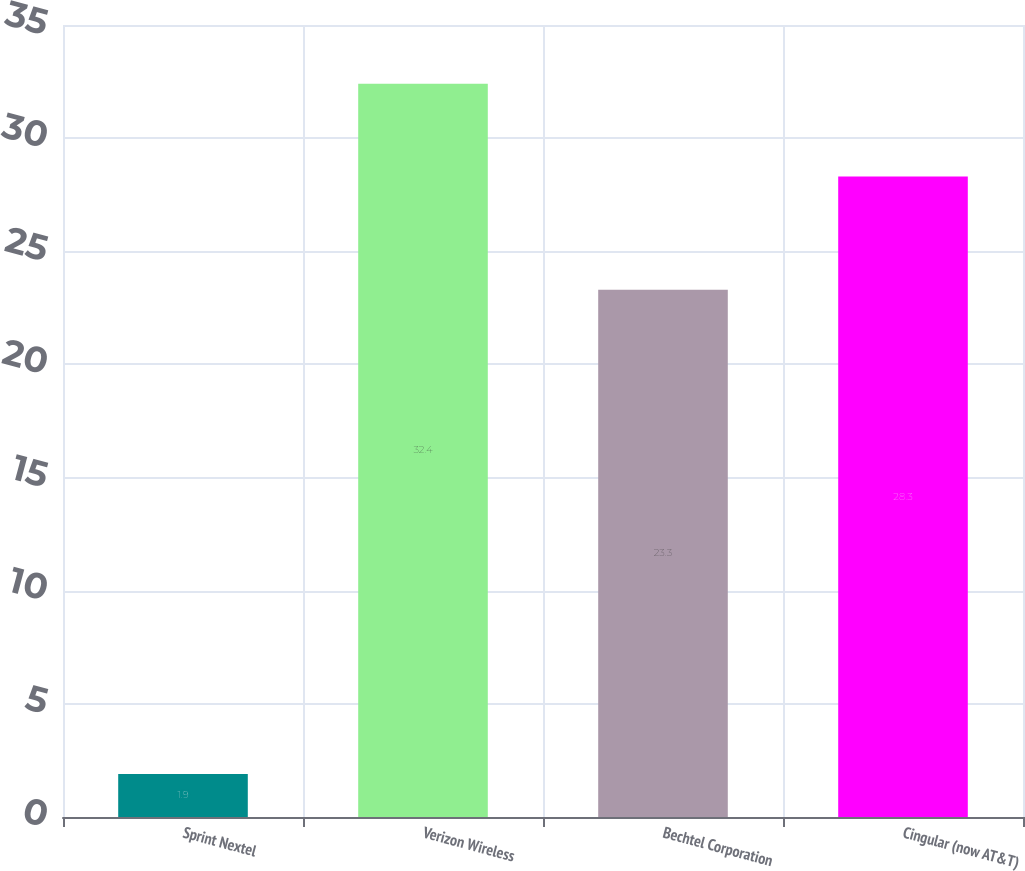Convert chart to OTSL. <chart><loc_0><loc_0><loc_500><loc_500><bar_chart><fcel>Sprint Nextel<fcel>Verizon Wireless<fcel>Bechtel Corporation<fcel>Cingular (now AT&T)<nl><fcel>1.9<fcel>32.4<fcel>23.3<fcel>28.3<nl></chart> 